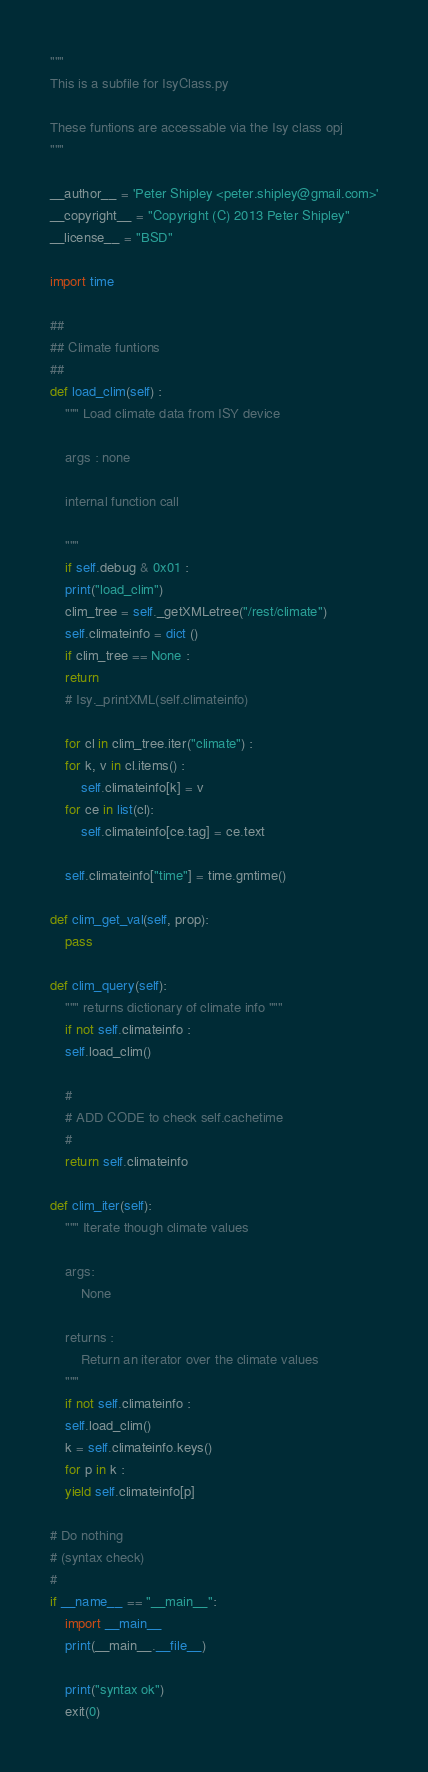Convert code to text. <code><loc_0><loc_0><loc_500><loc_500><_Python_>
"""
This is a subfile for IsyClass.py

These funtions are accessable via the Isy class opj
"""

__author__ = 'Peter Shipley <peter.shipley@gmail.com>'
__copyright__ = "Copyright (C) 2013 Peter Shipley"
__license__ = "BSD"

import time

##
## Climate funtions
##
def load_clim(self) :
    """ Load climate data from ISY device

	args : none

	internal function call

    """
    if self.debug & 0x01 :
	print("load_clim")
    clim_tree = self._getXMLetree("/rest/climate")
    self.climateinfo = dict ()
    if clim_tree == None :
	return 
    # Isy._printXML(self.climateinfo)

    for cl in clim_tree.iter("climate") :
	for k, v in cl.items() :
	    self.climateinfo[k] = v
	for ce in list(cl):
	    self.climateinfo[ce.tag] = ce.text

    self.climateinfo["time"] = time.gmtime()

def clim_get_val(self, prop):
    pass

def clim_query(self):
    """ returns dictionary of climate info """
    if not self.climateinfo :
	self.load_clim()

    #
    # ADD CODE to check self.cachetime
    #
    return self.climateinfo

def clim_iter(self):
    """ Iterate though climate values

	args:  
	    None

	returns :
	    Return an iterator over the climate values
    """
    if not self.climateinfo :
	self.load_clim()
    k = self.climateinfo.keys()
    for p in k :
	yield self.climateinfo[p]

# Do nothing
# (syntax check)
#
if __name__ == "__main__":
    import __main__
    print(__main__.__file__)

    print("syntax ok")
    exit(0)
</code> 